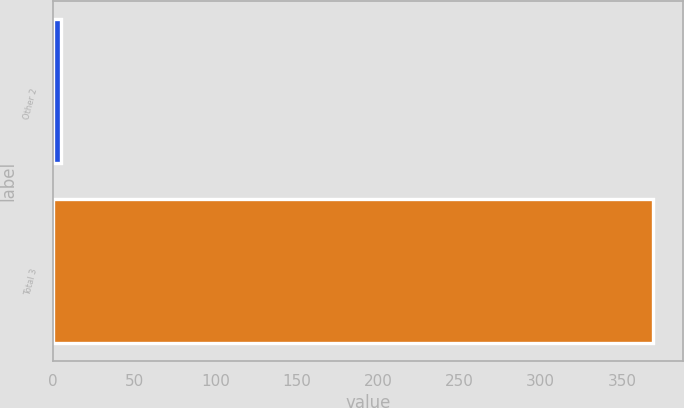Convert chart. <chart><loc_0><loc_0><loc_500><loc_500><bar_chart><fcel>Other 2<fcel>Total 3<nl><fcel>5<fcel>369<nl></chart> 